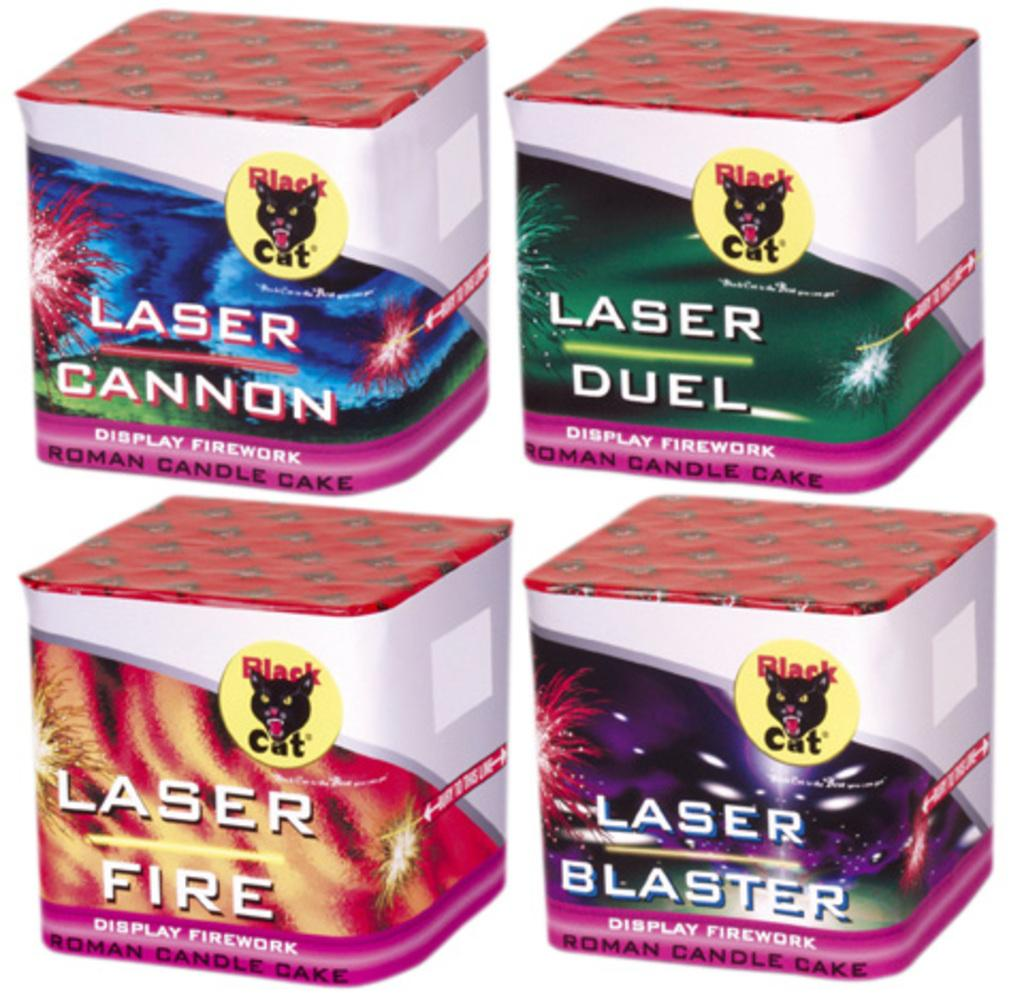Provide a one-sentence caption for the provided image. Four boxes of fireworks all contain the word laser in their name. 